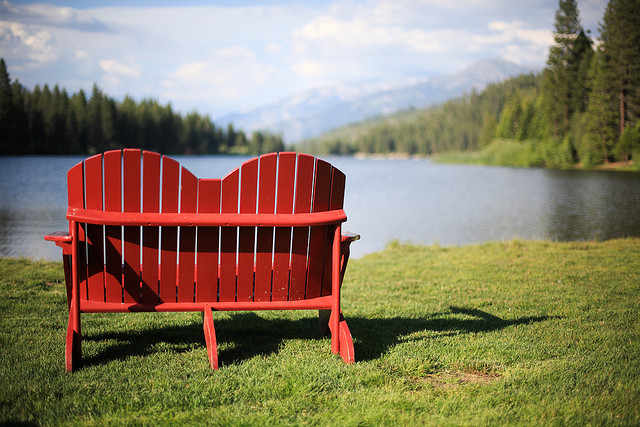What is the color of the bench facing the lake? The bench facing the lake is red, which creates a striking contrast against the natural colors of the lake and surroundings. 